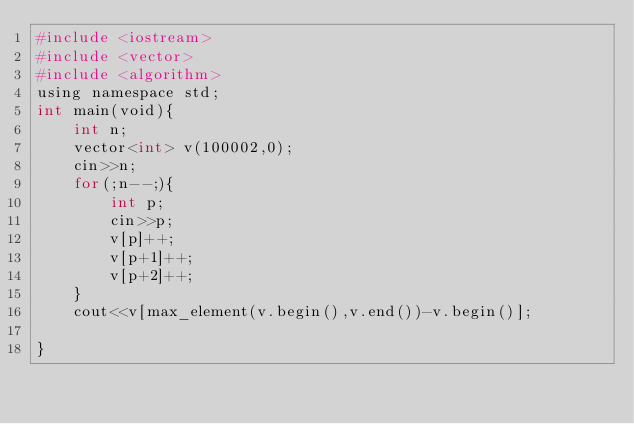Convert code to text. <code><loc_0><loc_0><loc_500><loc_500><_Python_>#include <iostream>
#include <vector>
#include <algorithm>
using namespace std;
int main(void){
    int n;
    vector<int> v(100002,0);
    cin>>n;
    for(;n--;){
        int p;
        cin>>p;
        v[p]++;
        v[p+1]++;
        v[p+2]++;
    }
    cout<<v[max_element(v.begin(),v.end())-v.begin()];
    
}
</code> 